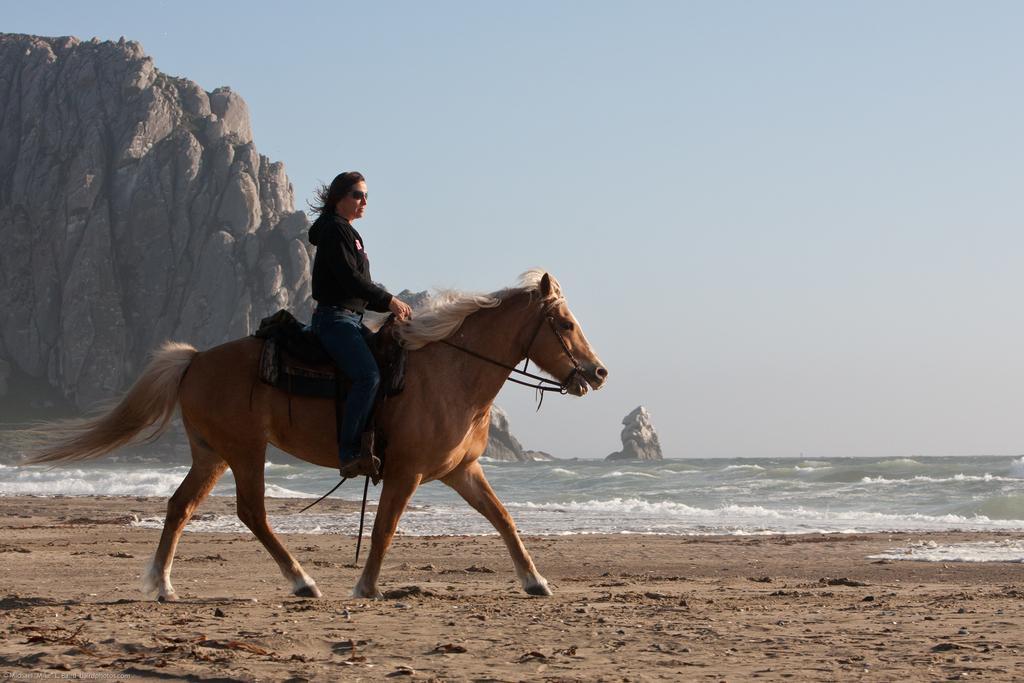Could you give a brief overview of what you see in this image? In this image the woman is sitting on the horse. At the back side there is a mountain and a water. 